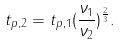Convert formula to latex. <formula><loc_0><loc_0><loc_500><loc_500>t _ { p , 2 } = t _ { p , 1 } ( \frac { \nu _ { 1 } } { \nu _ { 2 } } ) ^ { \frac { 2 } { 3 } } .</formula> 